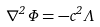Convert formula to latex. <formula><loc_0><loc_0><loc_500><loc_500>\nabla ^ { 2 } \Phi = - c ^ { 2 } \Lambda</formula> 